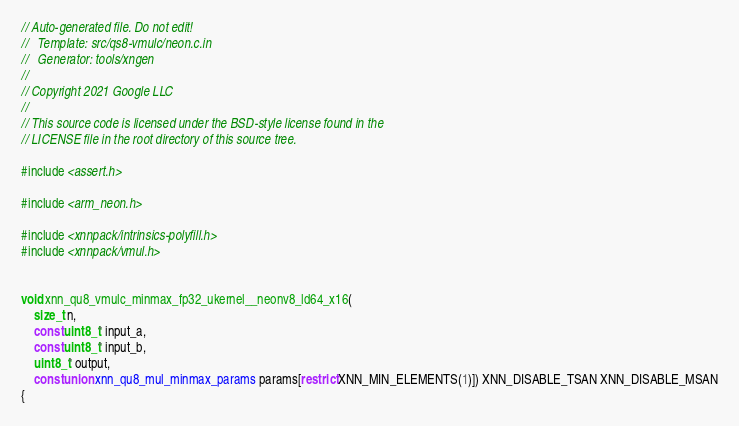<code> <loc_0><loc_0><loc_500><loc_500><_C_>// Auto-generated file. Do not edit!
//   Template: src/qs8-vmulc/neon.c.in
//   Generator: tools/xngen
//
// Copyright 2021 Google LLC
//
// This source code is licensed under the BSD-style license found in the
// LICENSE file in the root directory of this source tree.

#include <assert.h>

#include <arm_neon.h>

#include <xnnpack/intrinsics-polyfill.h>
#include <xnnpack/vmul.h>


void xnn_qu8_vmulc_minmax_fp32_ukernel__neonv8_ld64_x16(
    size_t n,
    const uint8_t* input_a,
    const uint8_t* input_b,
    uint8_t* output,
    const union xnn_qu8_mul_minmax_params params[restrict XNN_MIN_ELEMENTS(1)]) XNN_DISABLE_TSAN XNN_DISABLE_MSAN
{</code> 